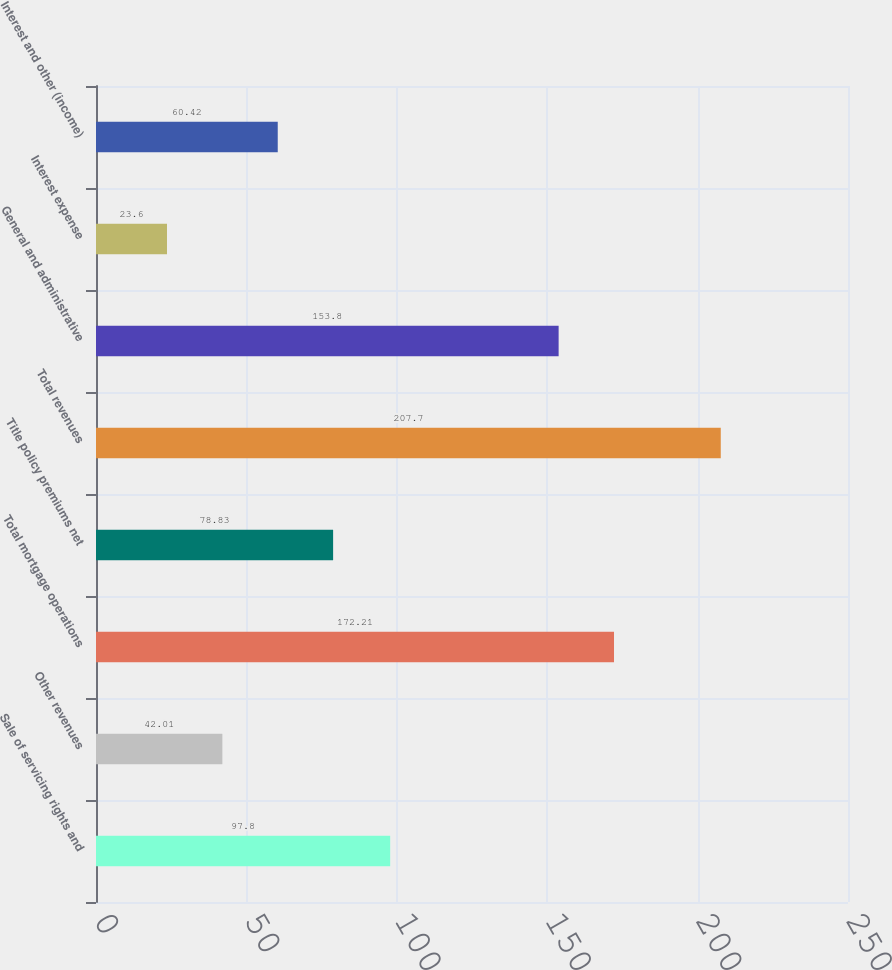<chart> <loc_0><loc_0><loc_500><loc_500><bar_chart><fcel>Sale of servicing rights and<fcel>Other revenues<fcel>Total mortgage operations<fcel>Title policy premiums net<fcel>Total revenues<fcel>General and administrative<fcel>Interest expense<fcel>Interest and other (income)<nl><fcel>97.8<fcel>42.01<fcel>172.21<fcel>78.83<fcel>207.7<fcel>153.8<fcel>23.6<fcel>60.42<nl></chart> 